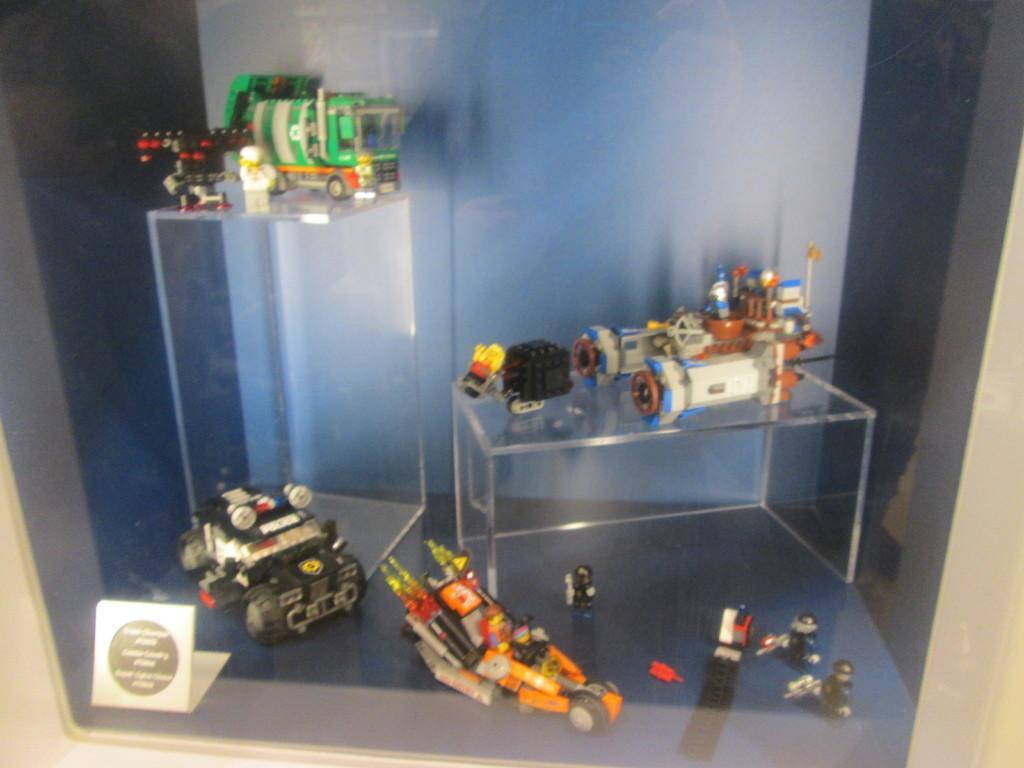Could you give a brief overview of what you see in this image? In this image I can see few toys on the glass surface. The toys are in multi color, background the wall is in white and black color. 